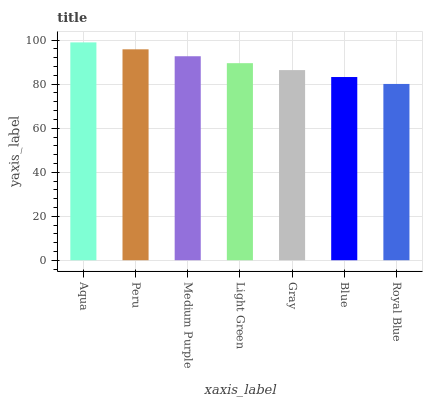Is Royal Blue the minimum?
Answer yes or no. Yes. Is Aqua the maximum?
Answer yes or no. Yes. Is Peru the minimum?
Answer yes or no. No. Is Peru the maximum?
Answer yes or no. No. Is Aqua greater than Peru?
Answer yes or no. Yes. Is Peru less than Aqua?
Answer yes or no. Yes. Is Peru greater than Aqua?
Answer yes or no. No. Is Aqua less than Peru?
Answer yes or no. No. Is Light Green the high median?
Answer yes or no. Yes. Is Light Green the low median?
Answer yes or no. Yes. Is Royal Blue the high median?
Answer yes or no. No. Is Aqua the low median?
Answer yes or no. No. 